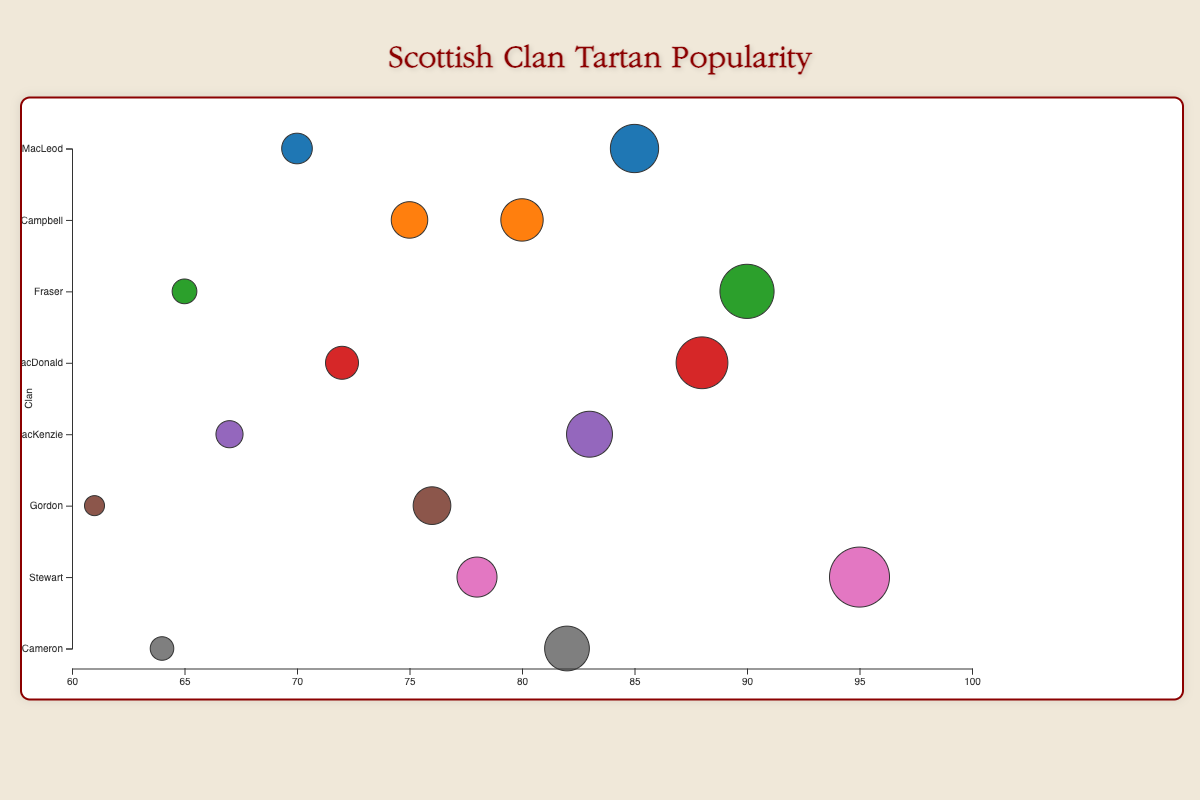What is the title of the chart? The title appears at the top of the chart, centered. In this case, it reads "Scottish Clan Tartan Popularity".
Answer: Scottish Clan Tartan Popularity Which clan has the most popular tartan pattern in the chart? By looking at the size of the bubbles, the "Royal Stewart" tartan of the Stewart clan has the largest bubble, indicating a popularity of 95.
Answer: Stewart How many tartan patterns are shown for the MacLeod clan? By identifying the clusters around the clan label 'MacLeod' on the vertical axis, we see two bubbles representing the tartan patterns "MacLeod of Harris" and "MacLeod Dress".
Answer: 2 Which tartan pattern from the Gordon clan is less popular? There are two bubbles for the Gordon clan. "Gordon Modern" is at 76 popularity, and "Gordon Dress" is at 61, so "Gordon Dress" is less popular.
Answer: Gordon Dress Compare the popularity of the two tartan patterns from the Cameron clan. The Cameron clan has "Cameron of Erracht" with a popularity of 82 and "Cameron Dress" with a popularity of 64.
Answer: Cameron of Erracht is more popular than Cameron Dress What is the range of tartan popularity values shown in the chart? The x-axis displays values from around 60 to 100, representing the range in popularity values. The minimum is 61 (Gordon Dress) and the maximum is 95 (Royal Stewart).
Answer: 61 to 95 What are the average popularity values for tartan patterns from the MacKenzie clan? The values are 83 for "MacKenzie Modern" and 67 for "MacKenzie Dress". (83 + 67) / 2 = 75
Answer: 75 Which clan has tartan patterns that are closest in popularity to each other? Comparing the distances between bubbles for each clan on the x-axis, the Campbell clan's patterns "Campbell of Breadalbane" (80) and "Campbell Dress" (75) have just a 5-point difference.
Answer: Campbell How does the popularity of "MacDonald of Clanranald" compare to "Fraser of Lovat"? Both patterns are represented by bubbles close to each other: "MacDonald of Clanranald" has a popularity of 88 and "Fraser of Lovat" has a popularity of 90.
Answer: Fraser of Lovat is more popular than MacDonald of Clanranald Which tartan pattern is least popular overall in the chart? By observing the smallest bubble, "Gordon Dress" has the smallest size and is located at 61 on the horizontal axis, representing its popularity.
Answer: Gordon Dress 